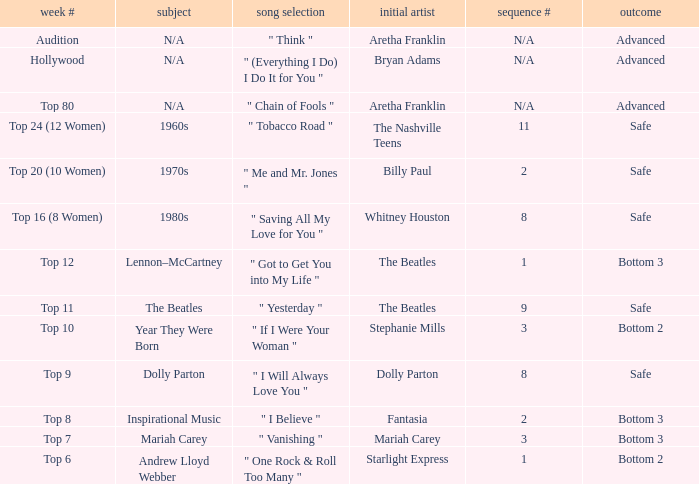Name the order number for the beatles and result is safe 9.0. 